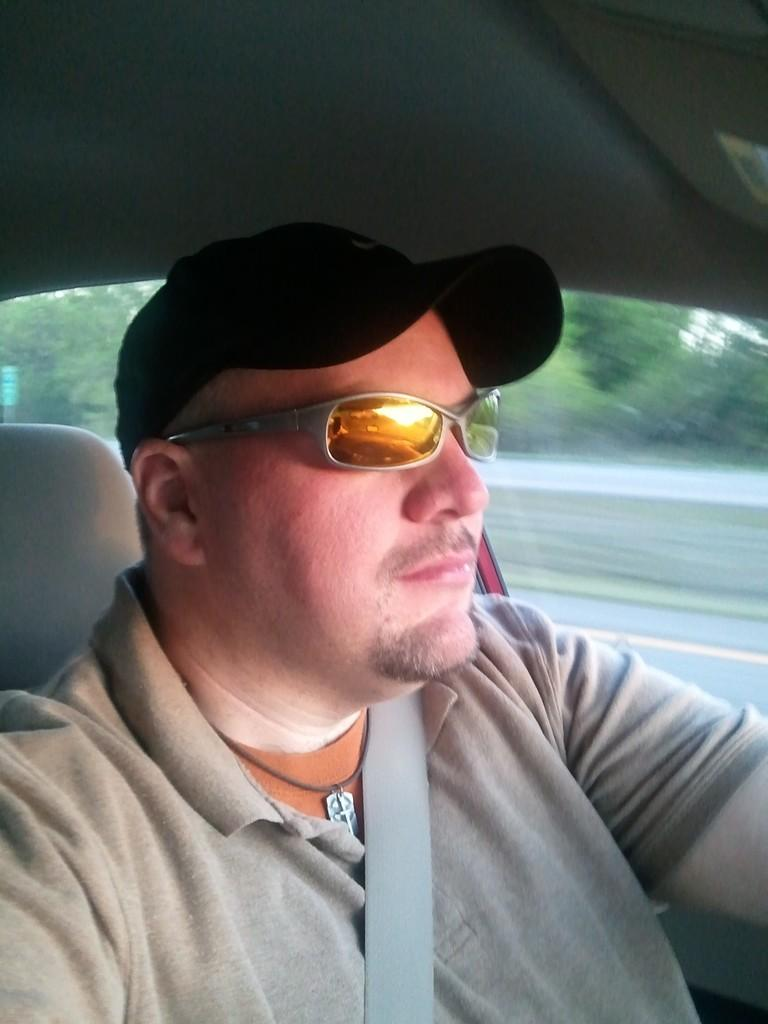What can be seen in the image related to a person? There is a person in the image. What accessories is the person wearing? The person is wearing a cap and specs. What color is the shirt the person is wearing? The person is wearing an ash color shirt. What safety feature is the person using in the image? The person is wearing seat belts. Where is the person located in the image? The person is sitting in a car. What type of shock can be seen affecting the person in the image? There is no shock present in the image; the person is sitting calmly in a car. Can you tell me how many airports are visible in the image? There are no airports present in the image; it features a person sitting in a car. 